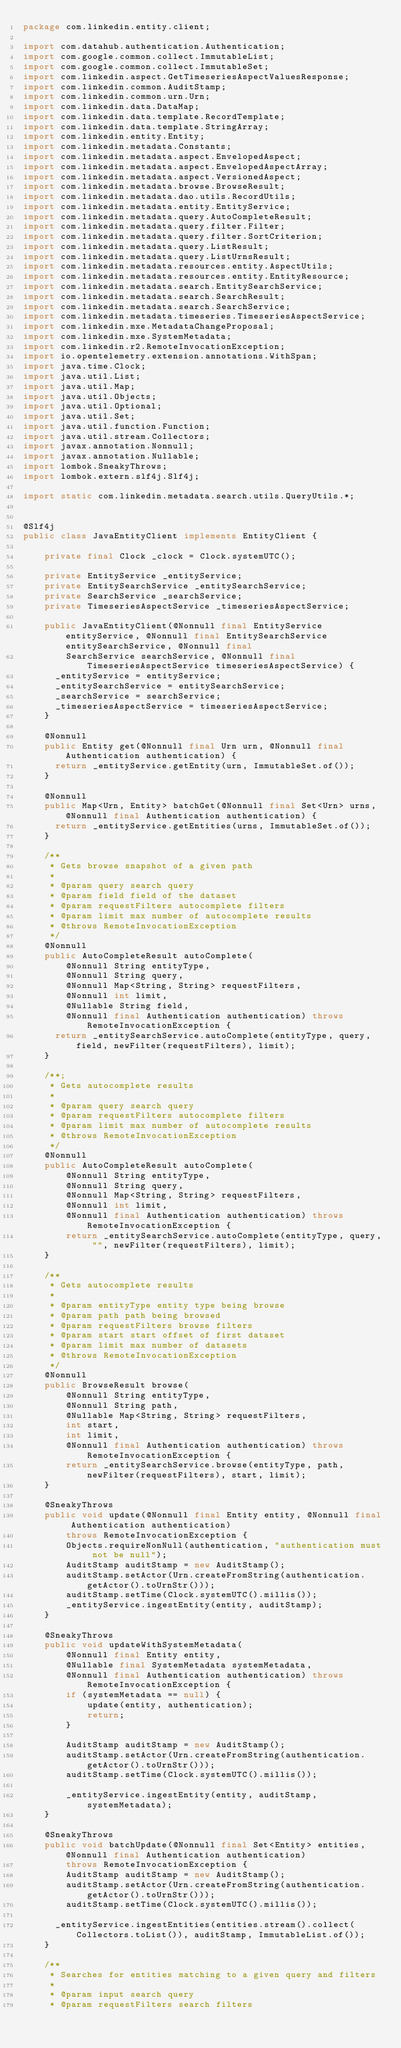Convert code to text. <code><loc_0><loc_0><loc_500><loc_500><_Java_>package com.linkedin.entity.client;

import com.datahub.authentication.Authentication;
import com.google.common.collect.ImmutableList;
import com.google.common.collect.ImmutableSet;
import com.linkedin.aspect.GetTimeseriesAspectValuesResponse;
import com.linkedin.common.AuditStamp;
import com.linkedin.common.urn.Urn;
import com.linkedin.data.DataMap;
import com.linkedin.data.template.RecordTemplate;
import com.linkedin.data.template.StringArray;
import com.linkedin.entity.Entity;
import com.linkedin.metadata.Constants;
import com.linkedin.metadata.aspect.EnvelopedAspect;
import com.linkedin.metadata.aspect.EnvelopedAspectArray;
import com.linkedin.metadata.aspect.VersionedAspect;
import com.linkedin.metadata.browse.BrowseResult;
import com.linkedin.metadata.dao.utils.RecordUtils;
import com.linkedin.metadata.entity.EntityService;
import com.linkedin.metadata.query.AutoCompleteResult;
import com.linkedin.metadata.query.filter.Filter;
import com.linkedin.metadata.query.filter.SortCriterion;
import com.linkedin.metadata.query.ListResult;
import com.linkedin.metadata.query.ListUrnsResult;
import com.linkedin.metadata.resources.entity.AspectUtils;
import com.linkedin.metadata.resources.entity.EntityResource;
import com.linkedin.metadata.search.EntitySearchService;
import com.linkedin.metadata.search.SearchResult;
import com.linkedin.metadata.search.SearchService;
import com.linkedin.metadata.timeseries.TimeseriesAspectService;
import com.linkedin.mxe.MetadataChangeProposal;
import com.linkedin.mxe.SystemMetadata;
import com.linkedin.r2.RemoteInvocationException;
import io.opentelemetry.extension.annotations.WithSpan;
import java.time.Clock;
import java.util.List;
import java.util.Map;
import java.util.Objects;
import java.util.Optional;
import java.util.Set;
import java.util.function.Function;
import java.util.stream.Collectors;
import javax.annotation.Nonnull;
import javax.annotation.Nullable;
import lombok.SneakyThrows;
import lombok.extern.slf4j.Slf4j;

import static com.linkedin.metadata.search.utils.QueryUtils.*;


@Slf4j
public class JavaEntityClient implements EntityClient {

    private final Clock _clock = Clock.systemUTC();

    private EntityService _entityService;
    private EntitySearchService _entitySearchService;
    private SearchService _searchService;
    private TimeseriesAspectService _timeseriesAspectService;

    public JavaEntityClient(@Nonnull final EntityService entityService, @Nonnull final EntitySearchService entitySearchService, @Nonnull final
        SearchService searchService, @Nonnull final TimeseriesAspectService timeseriesAspectService) {
      _entityService = entityService;
      _entitySearchService = entitySearchService;
      _searchService = searchService;
      _timeseriesAspectService = timeseriesAspectService;
    }

    @Nonnull
    public Entity get(@Nonnull final Urn urn, @Nonnull final Authentication authentication) {
      return _entityService.getEntity(urn, ImmutableSet.of());
    }

    @Nonnull
    public Map<Urn, Entity> batchGet(@Nonnull final Set<Urn> urns, @Nonnull final Authentication authentication) {
      return _entityService.getEntities(urns, ImmutableSet.of());
    }

    /**
     * Gets browse snapshot of a given path
     *
     * @param query search query
     * @param field field of the dataset
     * @param requestFilters autocomplete filters
     * @param limit max number of autocomplete results
     * @throws RemoteInvocationException
     */
    @Nonnull
    public AutoCompleteResult autoComplete(
        @Nonnull String entityType,
        @Nonnull String query,
        @Nonnull Map<String, String> requestFilters,
        @Nonnull int limit,
        @Nullable String field,
        @Nonnull final Authentication authentication) throws RemoteInvocationException {
      return _entitySearchService.autoComplete(entityType, query, field, newFilter(requestFilters), limit);
    }

    /**;
     * Gets autocomplete results
     *
     * @param query search query
     * @param requestFilters autocomplete filters
     * @param limit max number of autocomplete results
     * @throws RemoteInvocationException
     */
    @Nonnull
    public AutoCompleteResult autoComplete(
        @Nonnull String entityType,
        @Nonnull String query,
        @Nonnull Map<String, String> requestFilters,
        @Nonnull int limit,
        @Nonnull final Authentication authentication) throws RemoteInvocationException {
        return _entitySearchService.autoComplete(entityType, query, "", newFilter(requestFilters), limit);
    }

    /**
     * Gets autocomplete results
     *
     * @param entityType entity type being browse
     * @param path path being browsed
     * @param requestFilters browse filters
     * @param start start offset of first dataset
     * @param limit max number of datasets
     * @throws RemoteInvocationException
     */
    @Nonnull
    public BrowseResult browse(
        @Nonnull String entityType,
        @Nonnull String path,
        @Nullable Map<String, String> requestFilters,
        int start,
        int limit,
        @Nonnull final Authentication authentication) throws RemoteInvocationException {
        return _entitySearchService.browse(entityType, path, newFilter(requestFilters), start, limit);
    }

    @SneakyThrows
    public void update(@Nonnull final Entity entity, @Nonnull final Authentication authentication)
        throws RemoteInvocationException {
        Objects.requireNonNull(authentication, "authentication must not be null");
        AuditStamp auditStamp = new AuditStamp();
        auditStamp.setActor(Urn.createFromString(authentication.getActor().toUrnStr()));
        auditStamp.setTime(Clock.systemUTC().millis());
        _entityService.ingestEntity(entity, auditStamp);
    }

    @SneakyThrows
    public void updateWithSystemMetadata(
        @Nonnull final Entity entity,
        @Nullable final SystemMetadata systemMetadata,
        @Nonnull final Authentication authentication) throws RemoteInvocationException {
        if (systemMetadata == null) {
            update(entity, authentication);
            return;
        }

        AuditStamp auditStamp = new AuditStamp();
        auditStamp.setActor(Urn.createFromString(authentication.getActor().toUrnStr()));
        auditStamp.setTime(Clock.systemUTC().millis());

        _entityService.ingestEntity(entity, auditStamp, systemMetadata);
    }

    @SneakyThrows
    public void batchUpdate(@Nonnull final Set<Entity> entities, @Nonnull final Authentication authentication)
        throws RemoteInvocationException {
        AuditStamp auditStamp = new AuditStamp();
        auditStamp.setActor(Urn.createFromString(authentication.getActor().toUrnStr()));
        auditStamp.setTime(Clock.systemUTC().millis());

      _entityService.ingestEntities(entities.stream().collect(Collectors.toList()), auditStamp, ImmutableList.of());
    }

    /**
     * Searches for entities matching to a given query and filters
     *
     * @param input search query
     * @param requestFilters search filters</code> 